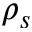<formula> <loc_0><loc_0><loc_500><loc_500>\rho _ { s }</formula> 